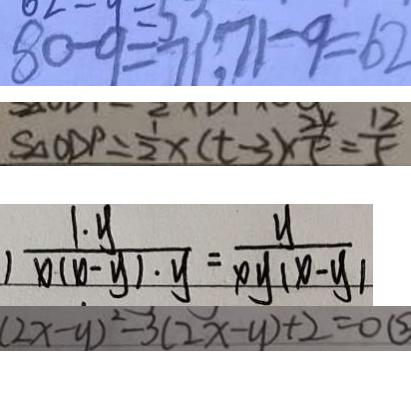<formula> <loc_0><loc_0><loc_500><loc_500>8 0 - 9 = 7 1 , 7 1 - 9 = 6 2 
 S _ { \Delta } O D P = \frac { 1 } { 2 } x ( t - 3 ) \times \frac { 2 4 } { 5 } = \frac { 1 2 } { 5 } 
 ) \frac { 1 \cdot y } { x ( x - y ) \cdot y } = \frac { y } { x y ( x - y ) } 
 ( 2 x - y ) ^ { 2 } - 3 ( 2 x - y ) + 2 = 0 \textcircled { 2 }</formula> 